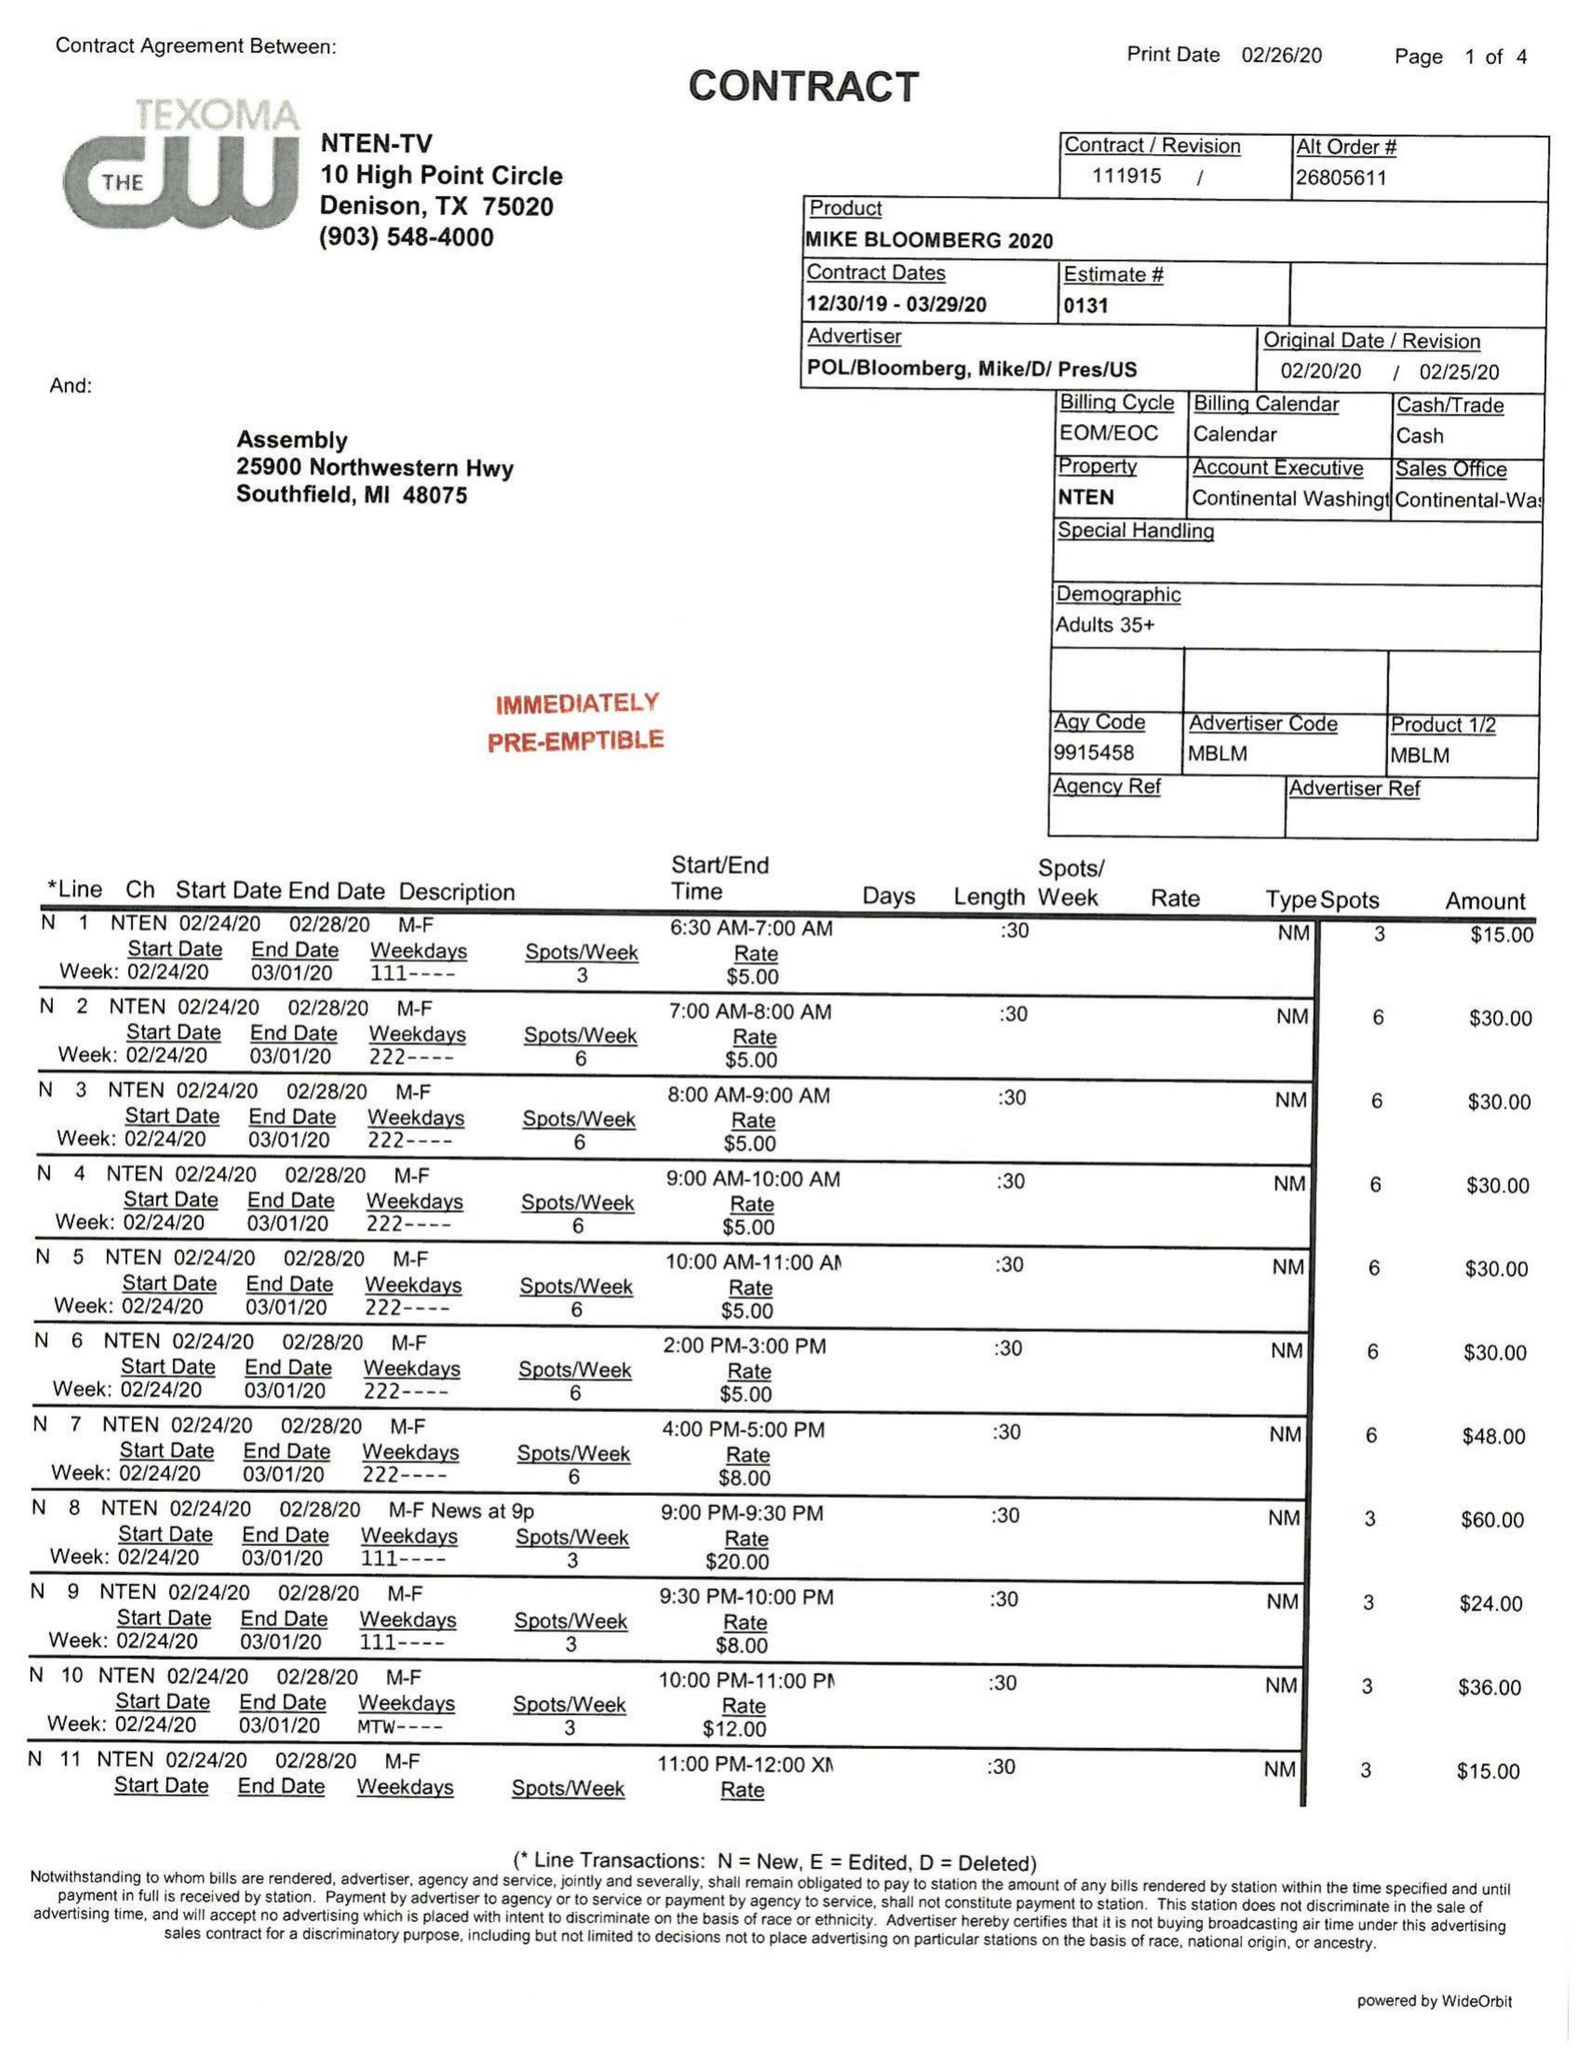What is the value for the gross_amount?
Answer the question using a single word or phrase. 1357.00 